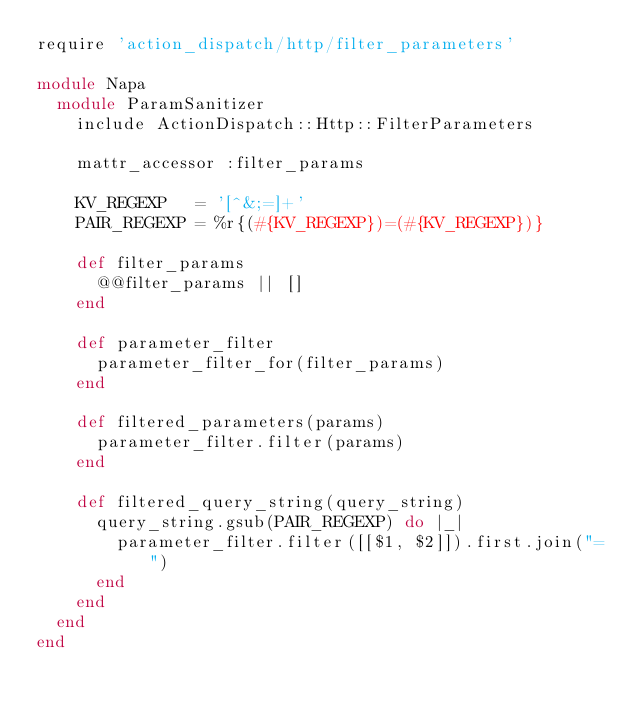Convert code to text. <code><loc_0><loc_0><loc_500><loc_500><_Ruby_>require 'action_dispatch/http/filter_parameters'

module Napa
  module ParamSanitizer
    include ActionDispatch::Http::FilterParameters

    mattr_accessor :filter_params

    KV_REGEXP   = '[^&;=]+'
    PAIR_REGEXP = %r{(#{KV_REGEXP})=(#{KV_REGEXP})}

    def filter_params
      @@filter_params || []
    end

    def parameter_filter
      parameter_filter_for(filter_params)
    end

    def filtered_parameters(params)
      parameter_filter.filter(params)
    end

    def filtered_query_string(query_string)
      query_string.gsub(PAIR_REGEXP) do |_|
        parameter_filter.filter([[$1, $2]]).first.join("=")
      end
    end
  end
end
</code> 